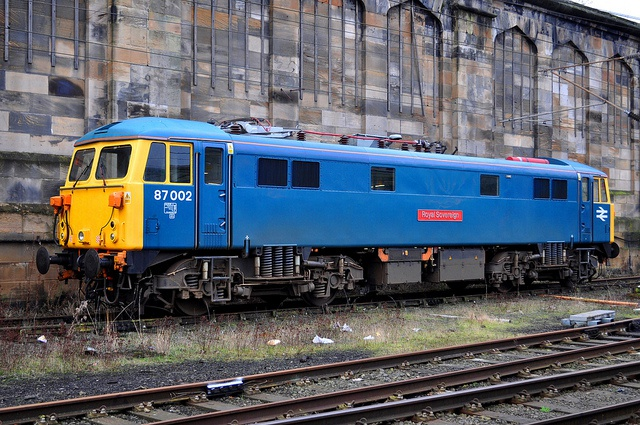Describe the objects in this image and their specific colors. I can see a train in black, blue, and gray tones in this image. 